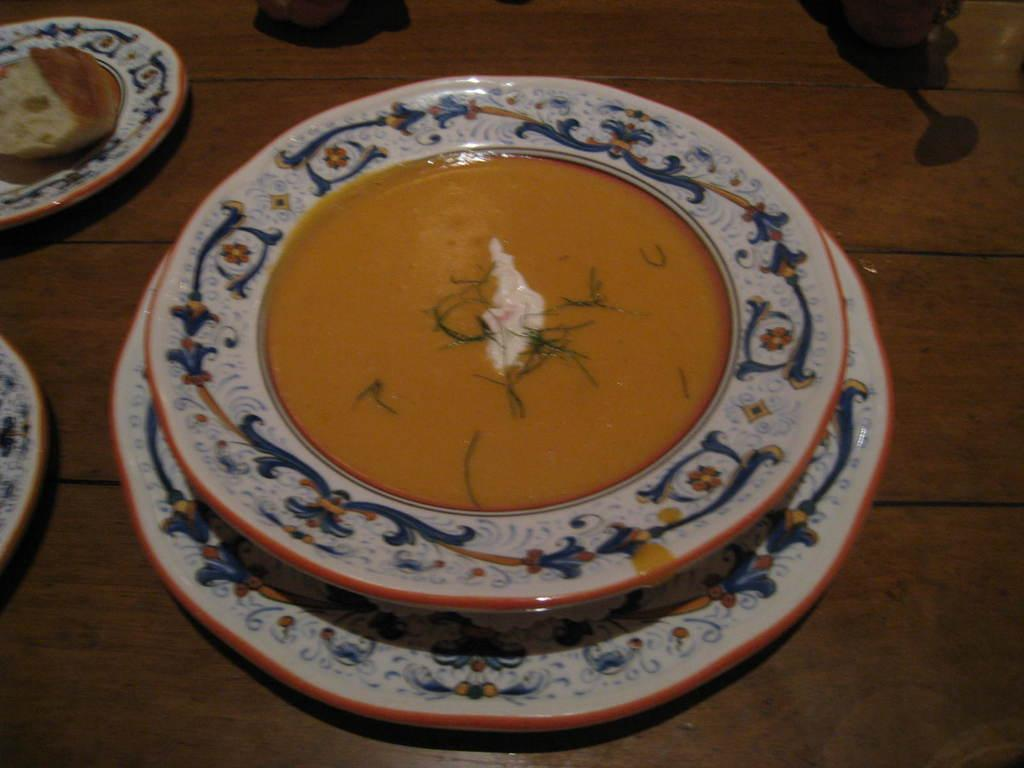What objects are present in the image that are typically used for serving food? There are plates in the image. What is the plates resting on? The plates are on a wooden object. What can be found on top of the plates? There are food items on the plates. What type of flowers can be seen growing on the wooden object in the image? There are no flowers present in the image; it only features plates and food items on a wooden object. 